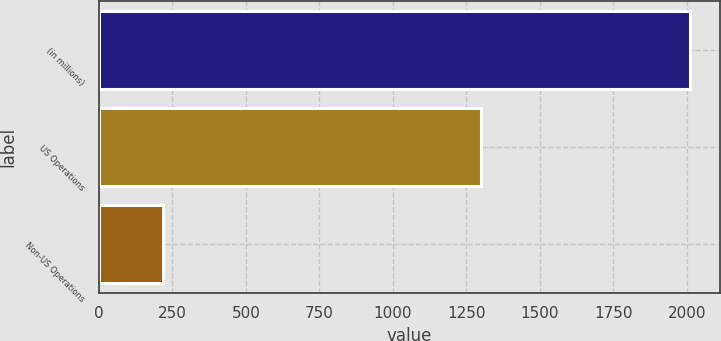Convert chart to OTSL. <chart><loc_0><loc_0><loc_500><loc_500><bar_chart><fcel>(in millions)<fcel>US Operations<fcel>Non-US Operations<nl><fcel>2011<fcel>1299.5<fcel>218.8<nl></chart> 